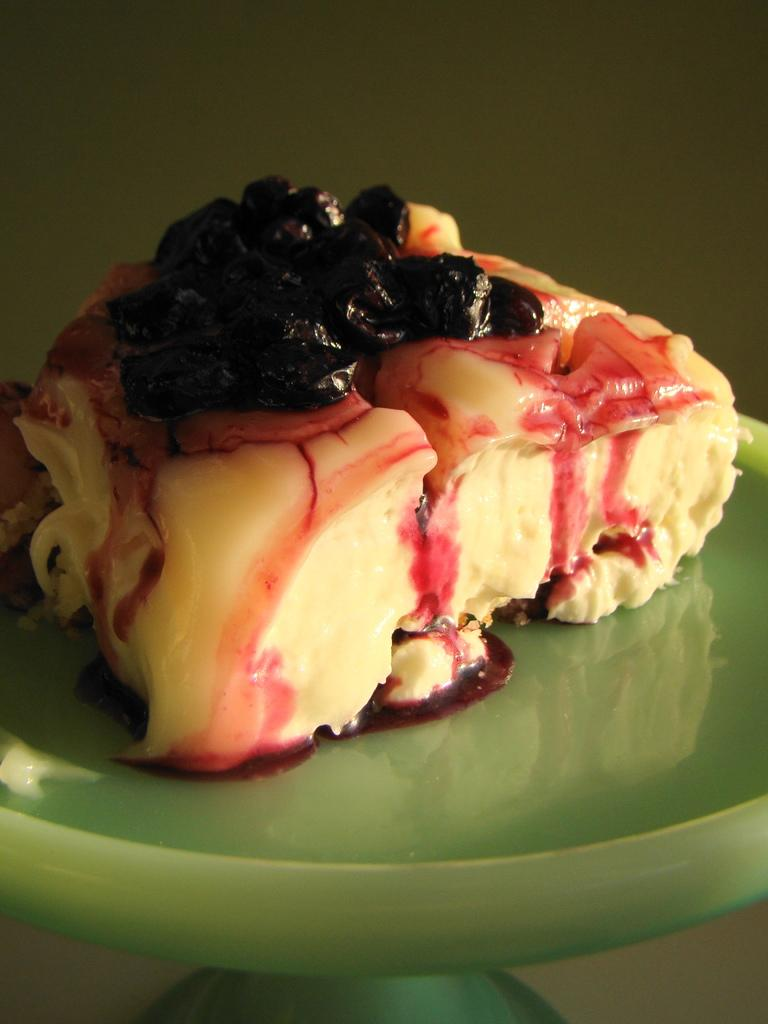What color is the plate in the image? The plate in the image is green in color. What is on the plate? There is an ice cream on the plate. What is the color of the ice cream? The ice cream is cream in color. What type of garnish is on the ice cream? The ice cream has black color fruit garnish on it. Is there a chair next to the plate in the image? There is no mention of a chair in the provided facts, so we cannot determine if there is one in the image. 